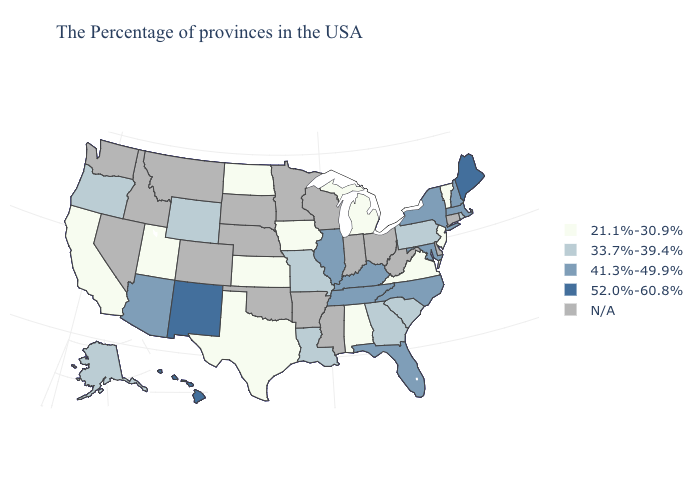Does Illinois have the highest value in the MidWest?
Give a very brief answer. Yes. What is the lowest value in states that border Utah?
Write a very short answer. 33.7%-39.4%. Does New Mexico have the highest value in the USA?
Keep it brief. Yes. Name the states that have a value in the range 33.7%-39.4%?
Keep it brief. Rhode Island, Pennsylvania, South Carolina, Georgia, Louisiana, Missouri, Wyoming, Oregon, Alaska. Does Alabama have the lowest value in the USA?
Quick response, please. Yes. Does the map have missing data?
Answer briefly. Yes. Name the states that have a value in the range 52.0%-60.8%?
Answer briefly. Maine, New Mexico, Hawaii. What is the value of Delaware?
Give a very brief answer. N/A. What is the lowest value in states that border Kentucky?
Write a very short answer. 21.1%-30.9%. What is the value of Colorado?
Concise answer only. N/A. What is the highest value in the USA?
Be succinct. 52.0%-60.8%. What is the value of Washington?
Keep it brief. N/A. Which states have the lowest value in the West?
Answer briefly. Utah, California. Which states hav the highest value in the West?
Quick response, please. New Mexico, Hawaii. Name the states that have a value in the range N/A?
Short answer required. Connecticut, Delaware, West Virginia, Ohio, Indiana, Wisconsin, Mississippi, Arkansas, Minnesota, Nebraska, Oklahoma, South Dakota, Colorado, Montana, Idaho, Nevada, Washington. 